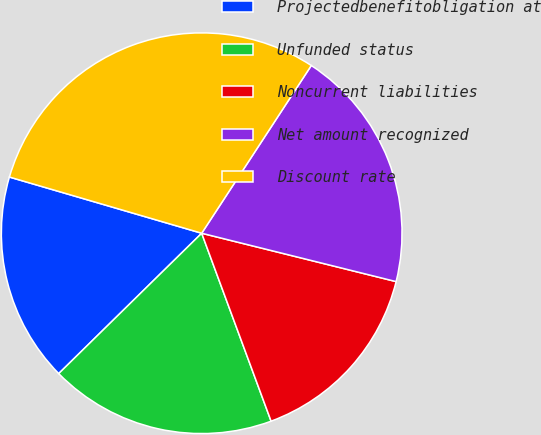<chart> <loc_0><loc_0><loc_500><loc_500><pie_chart><fcel>Projectedbenefitobligation at<fcel>Unfunded status<fcel>Noncurrent liabilities<fcel>Net amount recognized<fcel>Discount rate<nl><fcel>16.88%<fcel>18.28%<fcel>15.49%<fcel>19.67%<fcel>29.69%<nl></chart> 